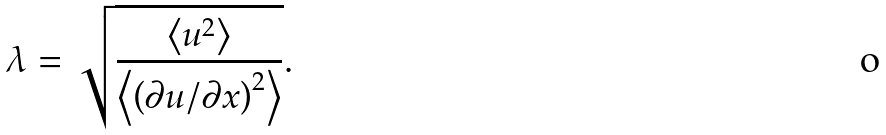<formula> <loc_0><loc_0><loc_500><loc_500>\lambda = \sqrt { \frac { \left \langle u ^ { 2 } \right \rangle } { \left \langle \left ( \partial u / \partial x \right ) ^ { 2 } \right \rangle } } .</formula> 